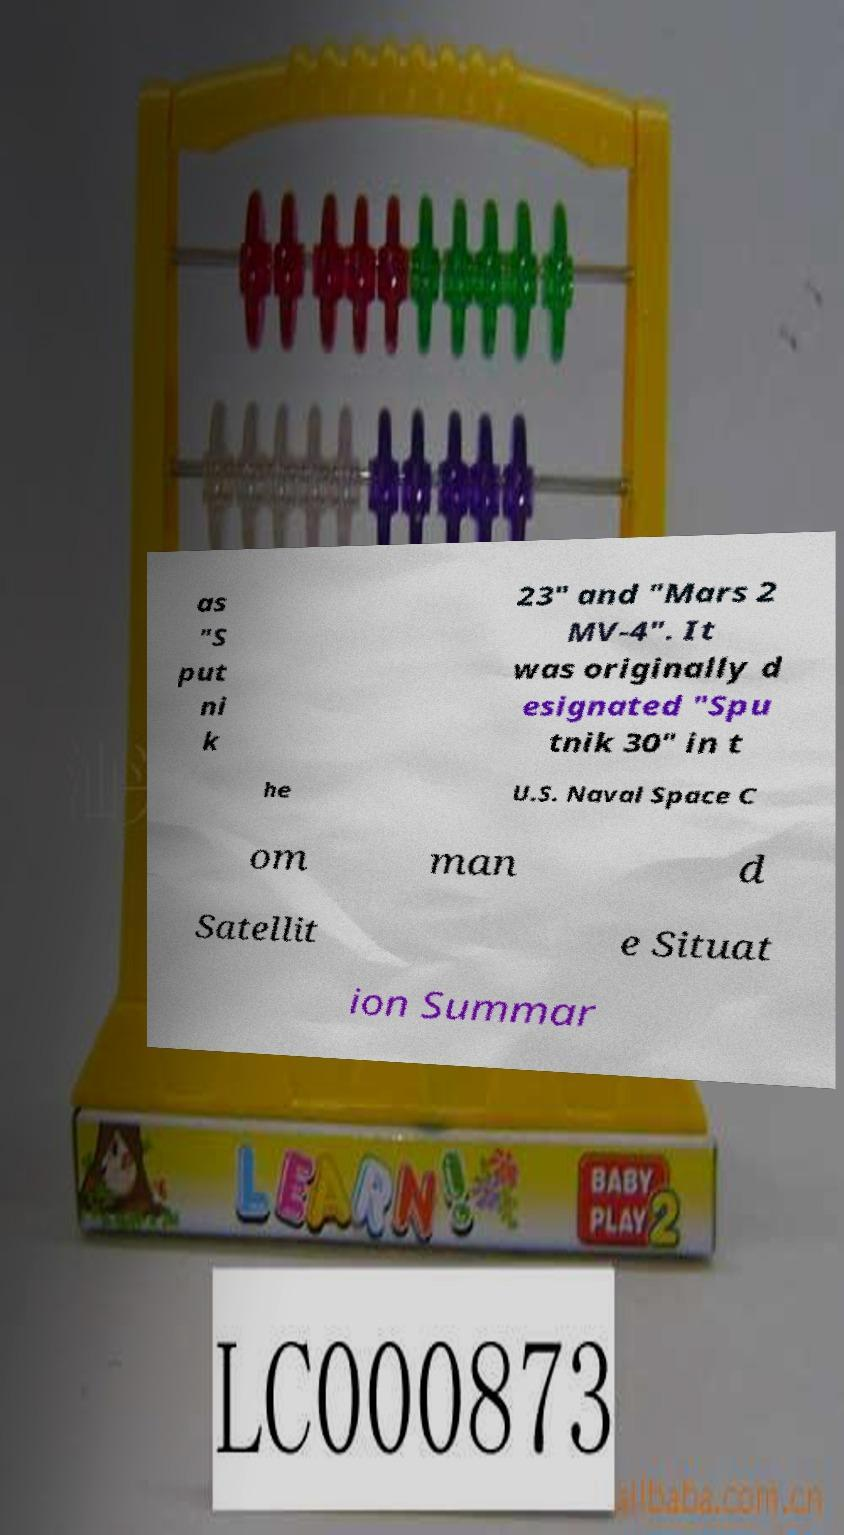Could you assist in decoding the text presented in this image and type it out clearly? as "S put ni k 23" and "Mars 2 MV-4". It was originally d esignated "Spu tnik 30" in t he U.S. Naval Space C om man d Satellit e Situat ion Summar 